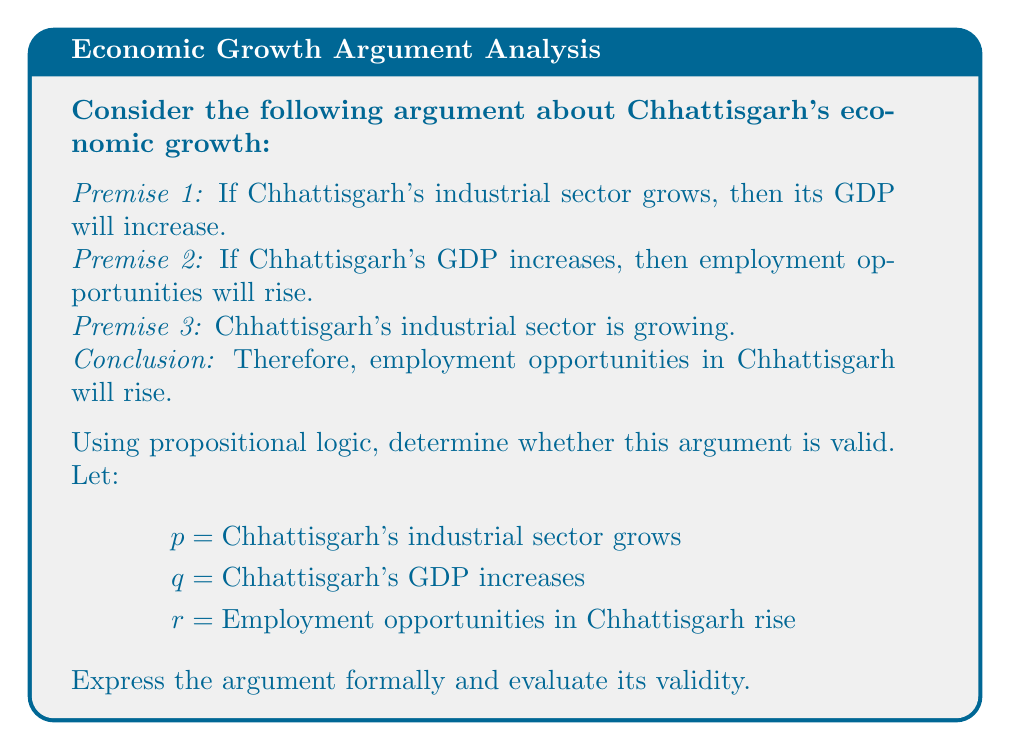What is the answer to this math problem? Let's approach this step-by-step:

1) First, we'll express the premises and conclusion using propositional logic:

   Premise 1: $p \rightarrow q$
   Premise 2: $q \rightarrow r$
   Premise 3: $p$
   Conclusion: $r$

2) The argument structure is:

   $$(p \rightarrow q) \land (q \rightarrow r) \land p \therefore r$$

3) This is a classic example of the logical rule of inference known as "hypothetical syllogism" combined with "modus ponens". Let's break it down:

   a) From $(p \rightarrow q)$ and $(q \rightarrow r)$, we can infer $(p \rightarrow r)$ by hypothetical syllogism.
   
   b) Now we have $(p \rightarrow r)$ and $p$, which allows us to conclude $r$ by modus ponens.

4) To formally prove validity, we can use a truth table or natural deduction. Here's a brief natural deduction:

   1. $p \rightarrow q$ (Premise 1)
   2. $q \rightarrow r$ (Premise 2)
   3. $p$ (Premise 3)
   4. $q$ (Modus Ponens, 1 and 3)
   5. $r$ (Modus Ponens, 2 and 4)

5) Since we can derive the conclusion from the premises using valid rules of inference, the argument is logically valid.

It's important to note that logical validity doesn't guarantee truth in the real world. It only ensures that if all premises are true, the conclusion must be true. The actual truth of the premises about Chhattisgarh's economy would need empirical verification.
Answer: Valid 